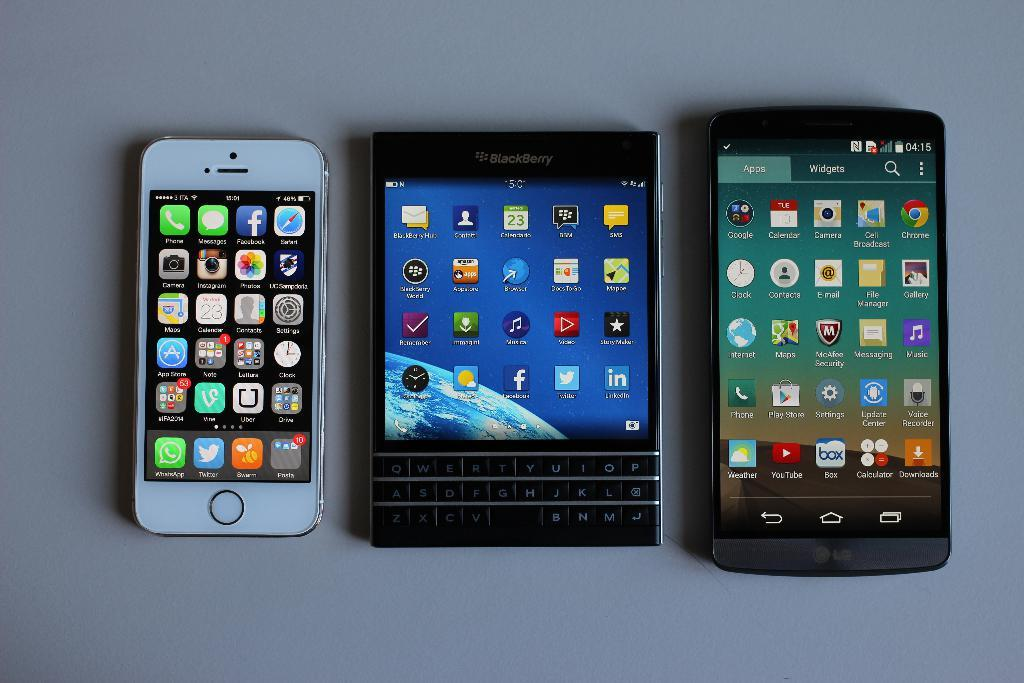<image>
Create a compact narrative representing the image presented. A Blackberry model is flanked by two smartphones. 